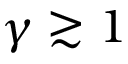<formula> <loc_0><loc_0><loc_500><loc_500>\gamma \gtrsim 1</formula> 